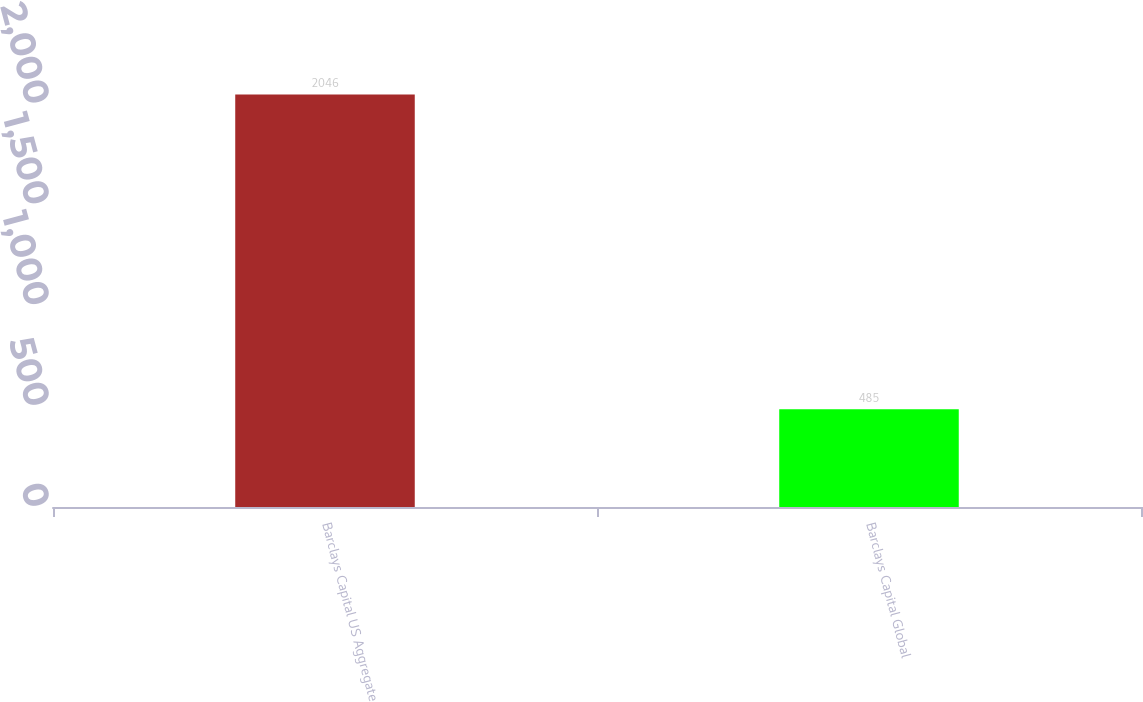<chart> <loc_0><loc_0><loc_500><loc_500><bar_chart><fcel>Barclays Capital US Aggregate<fcel>Barclays Capital Global<nl><fcel>2046<fcel>485<nl></chart> 